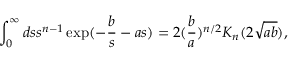<formula> <loc_0><loc_0><loc_500><loc_500>\int _ { 0 } ^ { \infty } d s s ^ { n - 1 } \exp ( - \frac { b } { s } - a s ) = 2 ( \frac { b } { a } ) ^ { n / 2 } K _ { n } ( 2 \sqrt { a b } ) ,</formula> 